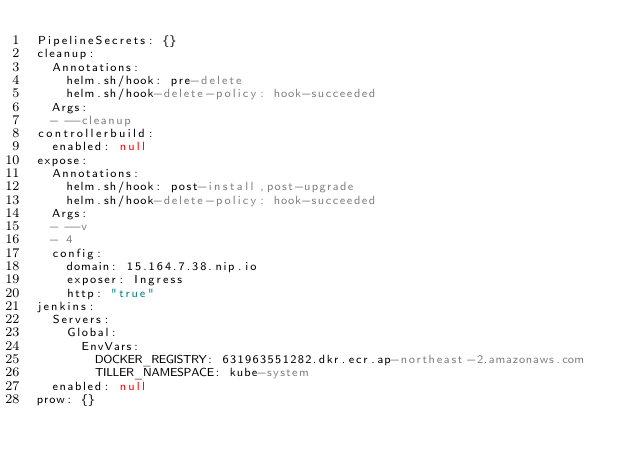<code> <loc_0><loc_0><loc_500><loc_500><_YAML_>PipelineSecrets: {}
cleanup:
  Annotations:
    helm.sh/hook: pre-delete
    helm.sh/hook-delete-policy: hook-succeeded
  Args:
  - --cleanup
controllerbuild:
  enabled: null
expose:
  Annotations:
    helm.sh/hook: post-install,post-upgrade
    helm.sh/hook-delete-policy: hook-succeeded
  Args:
  - --v
  - 4
  config:
    domain: 15.164.7.38.nip.io
    exposer: Ingress
    http: "true"
jenkins:
  Servers:
    Global:
      EnvVars:
        DOCKER_REGISTRY: 631963551282.dkr.ecr.ap-northeast-2.amazonaws.com
        TILLER_NAMESPACE: kube-system
  enabled: null
prow: {}
</code> 